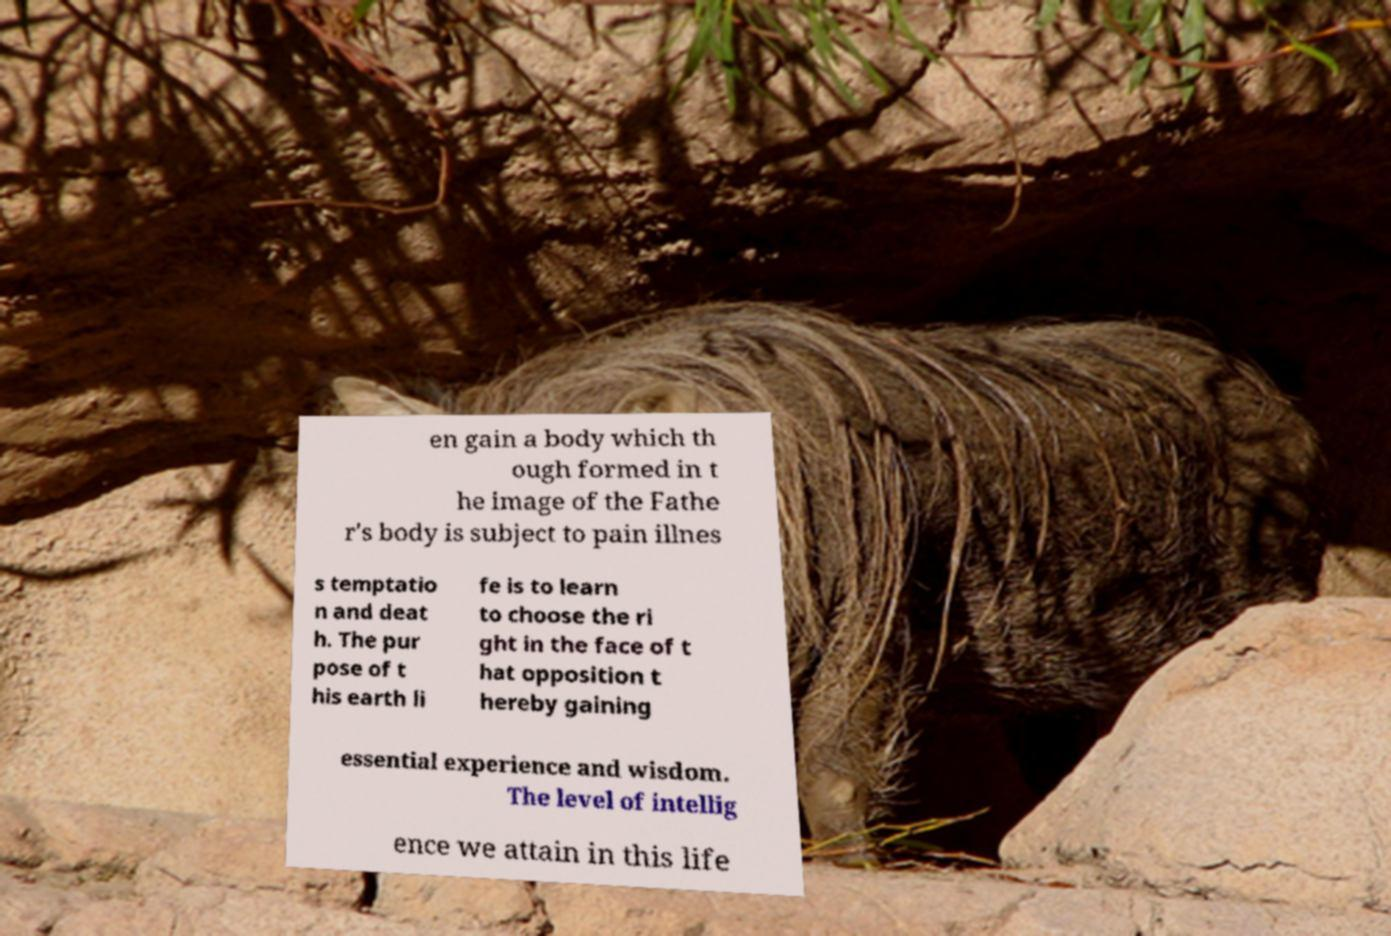Could you extract and type out the text from this image? en gain a body which th ough formed in t he image of the Fathe r's body is subject to pain illnes s temptatio n and deat h. The pur pose of t his earth li fe is to learn to choose the ri ght in the face of t hat opposition t hereby gaining essential experience and wisdom. The level of intellig ence we attain in this life 